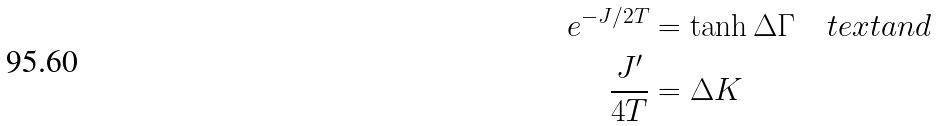Convert formula to latex. <formula><loc_0><loc_0><loc_500><loc_500>e ^ { - J / 2 T } & = \tanh \Delta \Gamma \quad t e x t { a n d } \\ \frac { J ^ { \prime } } { 4 T } & = \Delta K</formula> 